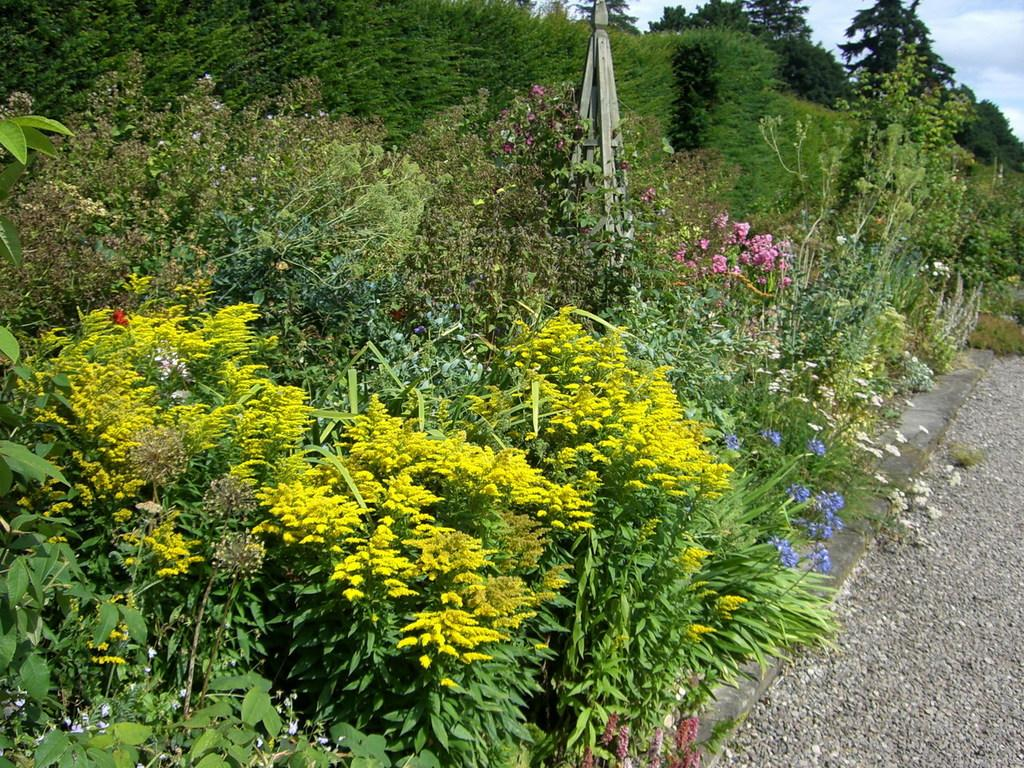What type of plants can be seen on the left side of the image? There are plants on the left side of the image. What type of plants are in the middle of the image? There are flower plants in the middle of the image. What type of lunch is being served in the image? There is no lunch present in the image; it features plants on the left side and flower plants in the middle. What news can be seen in the image? There is no news present in the image; it features plants and flower plants. 